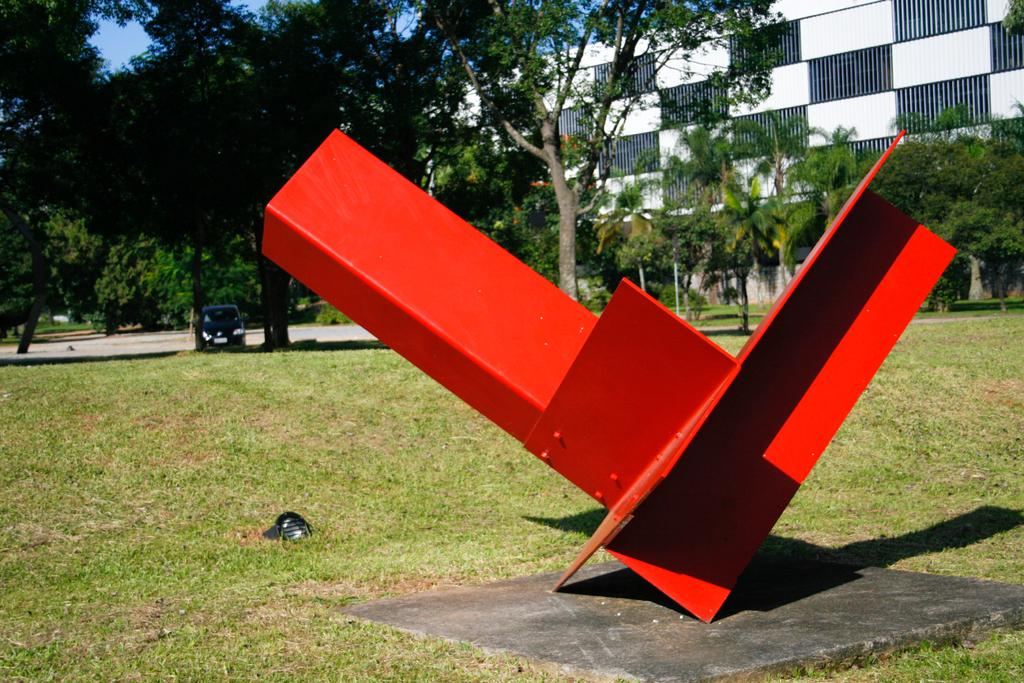What is the color of the object in the image? The object in the image is red in color. What can be seen in the background of the image? There are trees and the sky visible in the background of the image. What is the color of the trees in the image? The trees in the image are green in color. What is the color of the sky in the image? The sky in the image is blue in color. What is present on the road in the image? There is a vehicle on the road in the image. Can you hear someone coughing in the image? There is no sound present in the image, so it is not possible to hear someone coughing. What advertisement is being displayed on the trees in the image? There are no advertisements present on the trees in the image; they are simply trees in the background. 